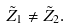Convert formula to latex. <formula><loc_0><loc_0><loc_500><loc_500>\tilde { Z } _ { 1 } \neq \tilde { Z } _ { 2 } .</formula> 